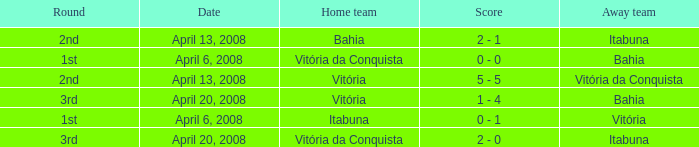Who was the home team on April 13, 2008 when Itabuna was the away team? Bahia. 